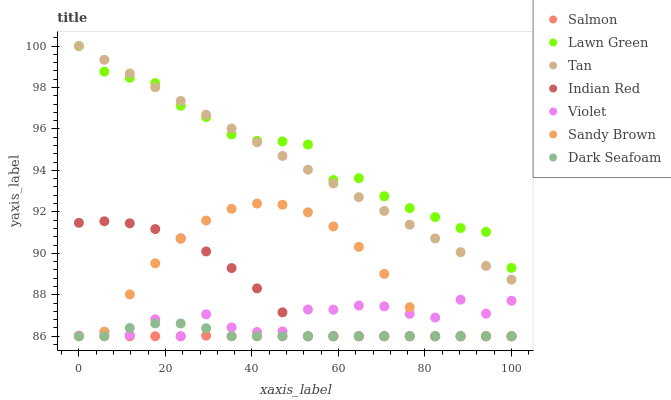Does Salmon have the minimum area under the curve?
Answer yes or no. Yes. Does Lawn Green have the maximum area under the curve?
Answer yes or no. Yes. Does Dark Seafoam have the minimum area under the curve?
Answer yes or no. No. Does Dark Seafoam have the maximum area under the curve?
Answer yes or no. No. Is Tan the smoothest?
Answer yes or no. Yes. Is Violet the roughest?
Answer yes or no. Yes. Is Salmon the smoothest?
Answer yes or no. No. Is Salmon the roughest?
Answer yes or no. No. Does Salmon have the lowest value?
Answer yes or no. Yes. Does Tan have the lowest value?
Answer yes or no. No. Does Tan have the highest value?
Answer yes or no. Yes. Does Dark Seafoam have the highest value?
Answer yes or no. No. Is Salmon less than Lawn Green?
Answer yes or no. Yes. Is Lawn Green greater than Dark Seafoam?
Answer yes or no. Yes. Does Indian Red intersect Salmon?
Answer yes or no. Yes. Is Indian Red less than Salmon?
Answer yes or no. No. Is Indian Red greater than Salmon?
Answer yes or no. No. Does Salmon intersect Lawn Green?
Answer yes or no. No. 